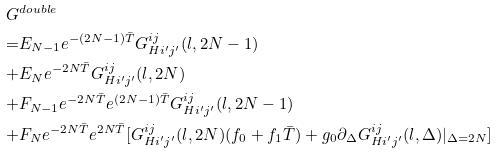Convert formula to latex. <formula><loc_0><loc_0><loc_500><loc_500>G & ^ { d o u b l e } \\ = & E _ { N - 1 } e ^ { - ( 2 N - 1 ) \bar { T } } G ^ { i j } _ { H i ^ { \prime } j ^ { \prime } } ( l , 2 N - 1 ) \\ + & E _ { N } e ^ { - 2 N \bar { T } } G ^ { i j } _ { H i ^ { \prime } j ^ { \prime } } ( l , 2 N ) \\ + & F _ { N - 1 } e ^ { - 2 N \bar { T } } e ^ { ( 2 N - 1 ) \bar { T } } G ^ { i j } _ { H i ^ { \prime } j ^ { \prime } } ( l , 2 N - 1 ) \\ + & F _ { N } e ^ { - 2 N \bar { T } } e ^ { 2 N \bar { T } } [ G ^ { i j } _ { H i ^ { \prime } j ^ { \prime } } ( l , 2 N ) ( f _ { 0 } + f _ { 1 } \bar { T } ) + g _ { 0 } \partial _ { \Delta } G ^ { i j } _ { H i ^ { \prime } j ^ { \prime } } ( l , \Delta ) | _ { \Delta = 2 N } ]</formula> 